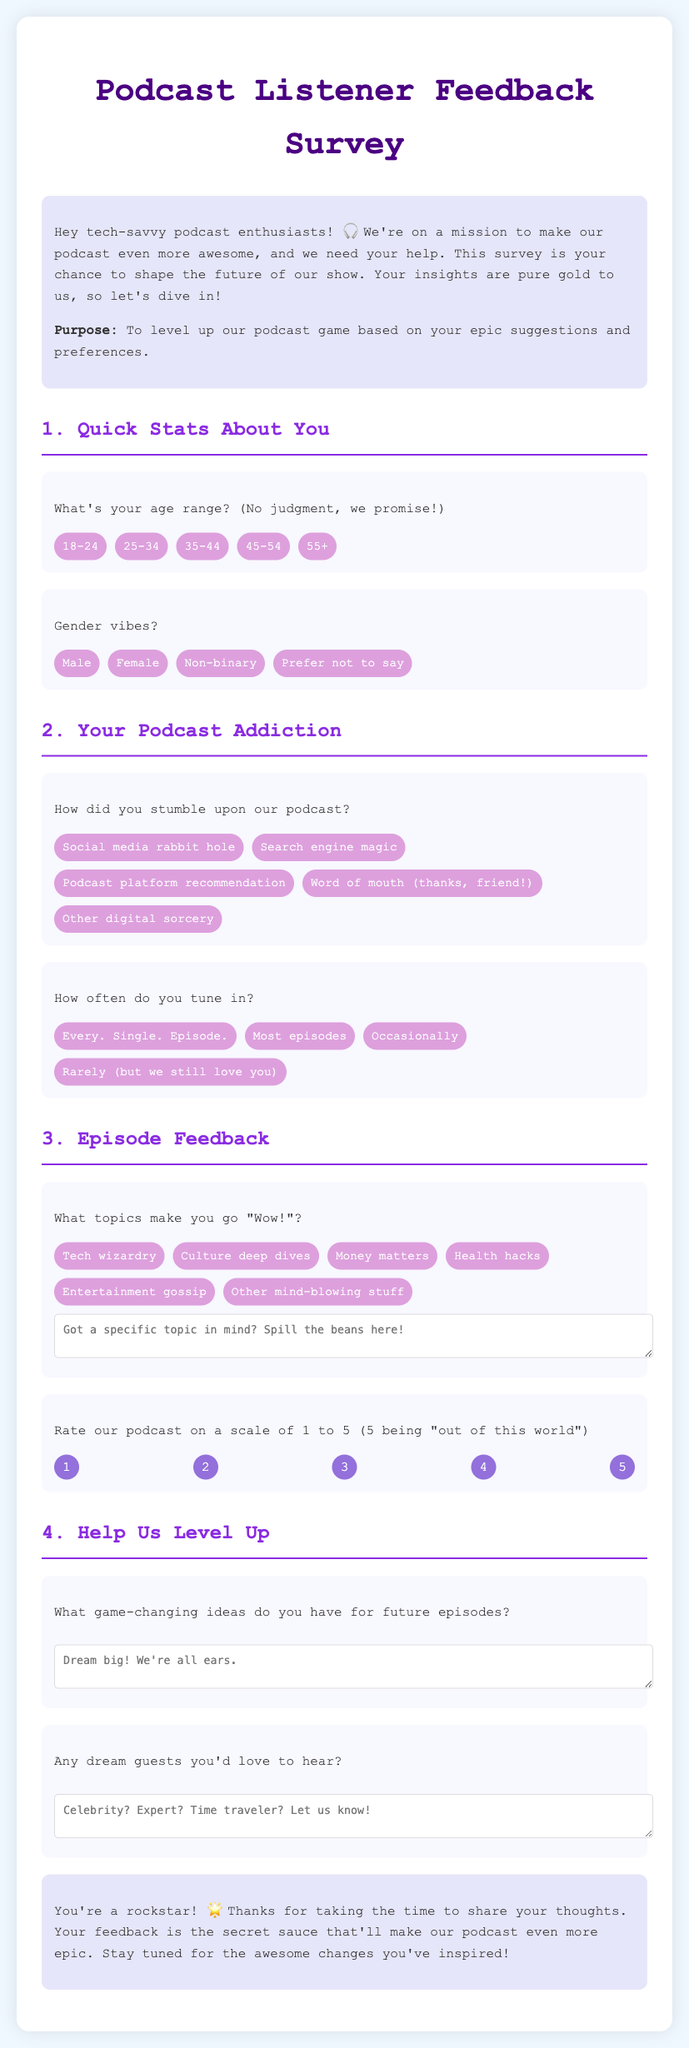What is the title of the survey? The title is prominently displayed at the top of the document, which is "Podcast Listener Feedback Survey".
Answer: Podcast Listener Feedback Survey What is the purpose of the survey? The purpose is clearly mentioned in the introduction section of the document as needed to make the podcast better with listener feedback.
Answer: To level up our podcast game based on your epic suggestions and preferences What age range option includes those under 18? The age range options provided do not include those under 18, starting from 18-24 and above.
Answer: None How often do listeners who respond to the survey tune in 'Every single episode'? A specific option is provided for this question in the "Your Podcast Addiction" section.
Answer: Every. Single. Episode How can listeners provide feedback about topics that amaze them? There is a section where listeners can specify topics and provide additional details in a textarea.
Answer: A specific textarea is provided for detailed feedback What rating does '5' represent for the podcast? The rating scale given in the document describes the highest rating as meaning extraordinary quality.
Answer: Out of this world What does the conclusion thank listeners for? The conclusion expresses gratitude for listeners taking the time to provide feedback through the survey.
Answer: Sharing your thoughts What kind of guests does the survey ask about? The survey seeks input on potential guests listeners would like to hear on the show.
Answer: Dream guests 